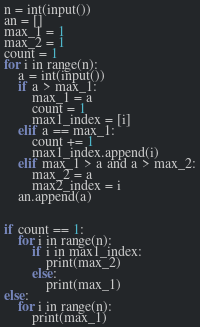Convert code to text. <code><loc_0><loc_0><loc_500><loc_500><_Python_>n = int(input())
an = []
max_1 = 1
max_2 = 1
count = 1
for i in range(n):
    a = int(input())
    if a > max_1:
        max_1 = a
        count = 1
        max1_index = [i]
    elif a == max_1:
        count += 1
        max1_index.append(i)
    elif max_1 > a and a > max_2:
        max_2 = a
        max2_index = i
    an.append(a)
    
    
if count == 1:
    for i in range(n):
        if i in max1_index:
            print(max_2)
        else:
            print(max_1)
else:
    for i in range(n):
        print(max_1)</code> 